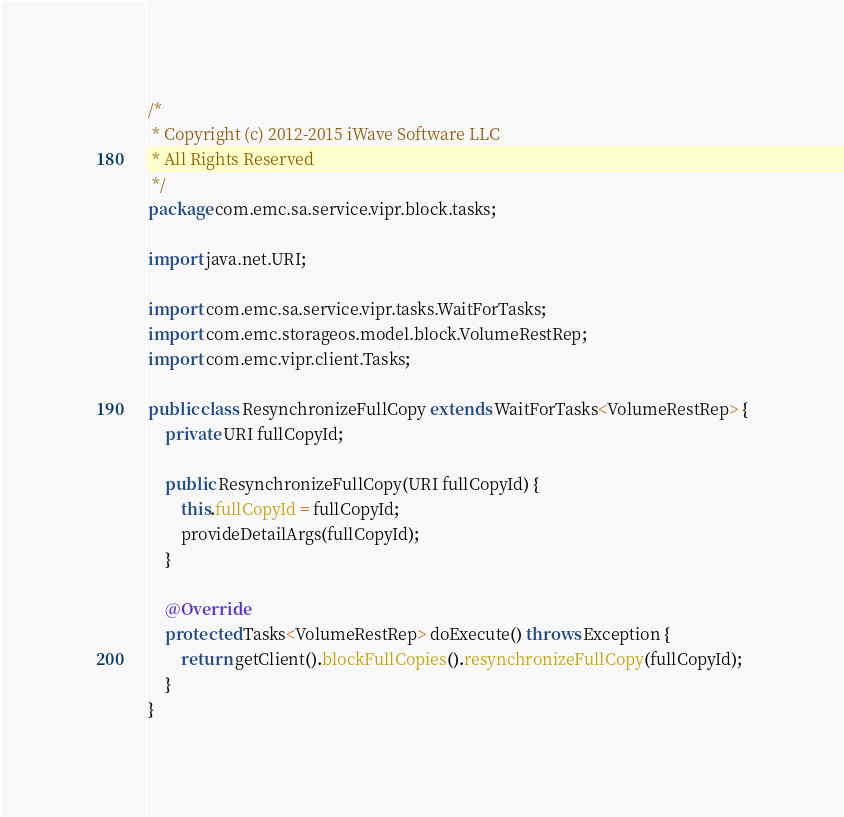Convert code to text. <code><loc_0><loc_0><loc_500><loc_500><_Java_>/*
 * Copyright (c) 2012-2015 iWave Software LLC
 * All Rights Reserved
 */
package com.emc.sa.service.vipr.block.tasks;

import java.net.URI;

import com.emc.sa.service.vipr.tasks.WaitForTasks;
import com.emc.storageos.model.block.VolumeRestRep;
import com.emc.vipr.client.Tasks;

public class ResynchronizeFullCopy extends WaitForTasks<VolumeRestRep> {
    private URI fullCopyId;

    public ResynchronizeFullCopy(URI fullCopyId) {
        this.fullCopyId = fullCopyId;
        provideDetailArgs(fullCopyId);
    }

    @Override
    protected Tasks<VolumeRestRep> doExecute() throws Exception {
        return getClient().blockFullCopies().resynchronizeFullCopy(fullCopyId);
    }
}
</code> 